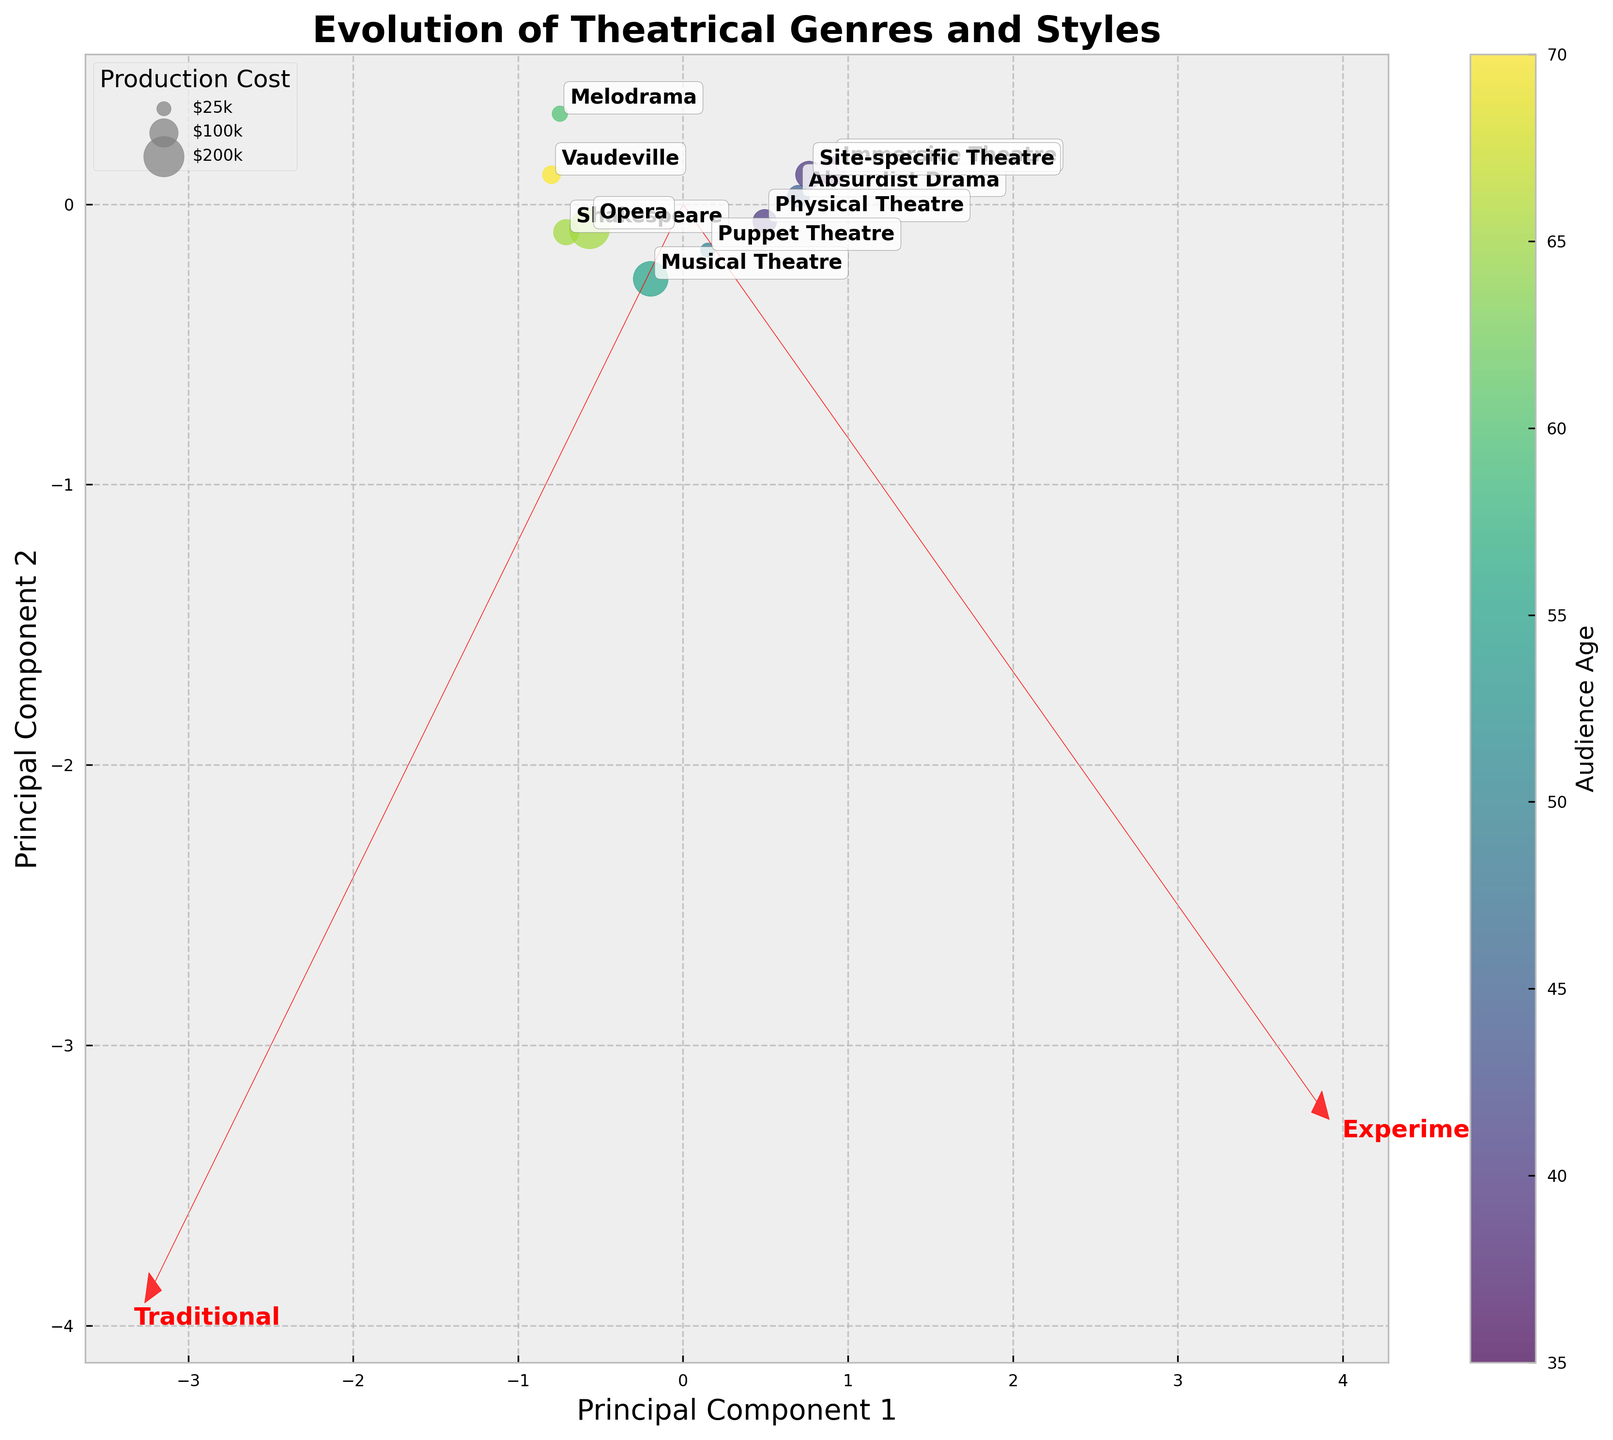How many genres are represented in the plot? To determine the number of genres, count the labeled points on the plot. Each labeled point represents a different genre.
Answer: 10 Which genre is associated with the highest production cost? Look for the largest bubble on the plot and identify the genre label associated with it. Bigger bubbles indicate higher production costs, and Opera appears to be the biggest.
Answer: Opera Which genre is categorized as highly experimental and has a relatively younger audience? The position of the genre in the biplot indicates its experimental/traditional value. Look for a genre with a high experimental value and reference the color gradient for younger audiences. Immersive Theatre fits this description.
Answer: Immersive Theatre Among Shakespeare and Absurdist Drama, which has an older audience? Compare the color shades representing audience age for Shakespeare and Absurdist Drama. The darker shade indicates an older audience, and Shakespeare appears darker.
Answer: Shakespeare What size are the bubbles of Musical Theatre and Puppet Theatre compared to each other? Compare the sizes of the bubbles representing Musical Theatre and Puppet Theatre. Musical Theatre has a larger bubble indicating higher production cost.
Answer: Musical Theatre's bubble is larger Which principal component axis is Physical Theatre closest to and what does this indicate? Physical Theatre's coordinates on the plot help determine its position relative to the axes. It is closer to the Experimental axis, indicating it leans more experimental.
Answer: Experimental How do the audience ages of Vaudeville and Site-specific Theatre compare? Contrast the bubble colors of Vaudeville and Site-specific Theatre. The darker the color, the older the audience. Vaudeville is darker than Site-specific Theatre, indicating an older audience.
Answer: Vaudeville has an older audience In terms of both Traditional and Experimental axes, which genre has the most balanced placement and what does this indicate about its style? Balanced placement means being near the center of the plot. Puppet Theatre is closest to the center, indicating it has both traditional and experimental elements.
Answer: Puppet Theatre How does the plot visually indicate the direction and strength of the traditional and experimental forms? The red arrows on the plot display the direction and length of the traditional and experimental components. The arrows' length represents the strength of each component. Experimental is longer, indicating it may have a stronger influence.
Answer: Red arrows; Experimental is stronger Considering both Audience Age and Production Cost, which genre shows the most significant correlation with younger audiences and high production costs? Identify the bubbles with a color indicating younger audiences and a larger size for higher production costs. Immersive Theatre has a brighter color and larger size.
Answer: Immersive Theatre 